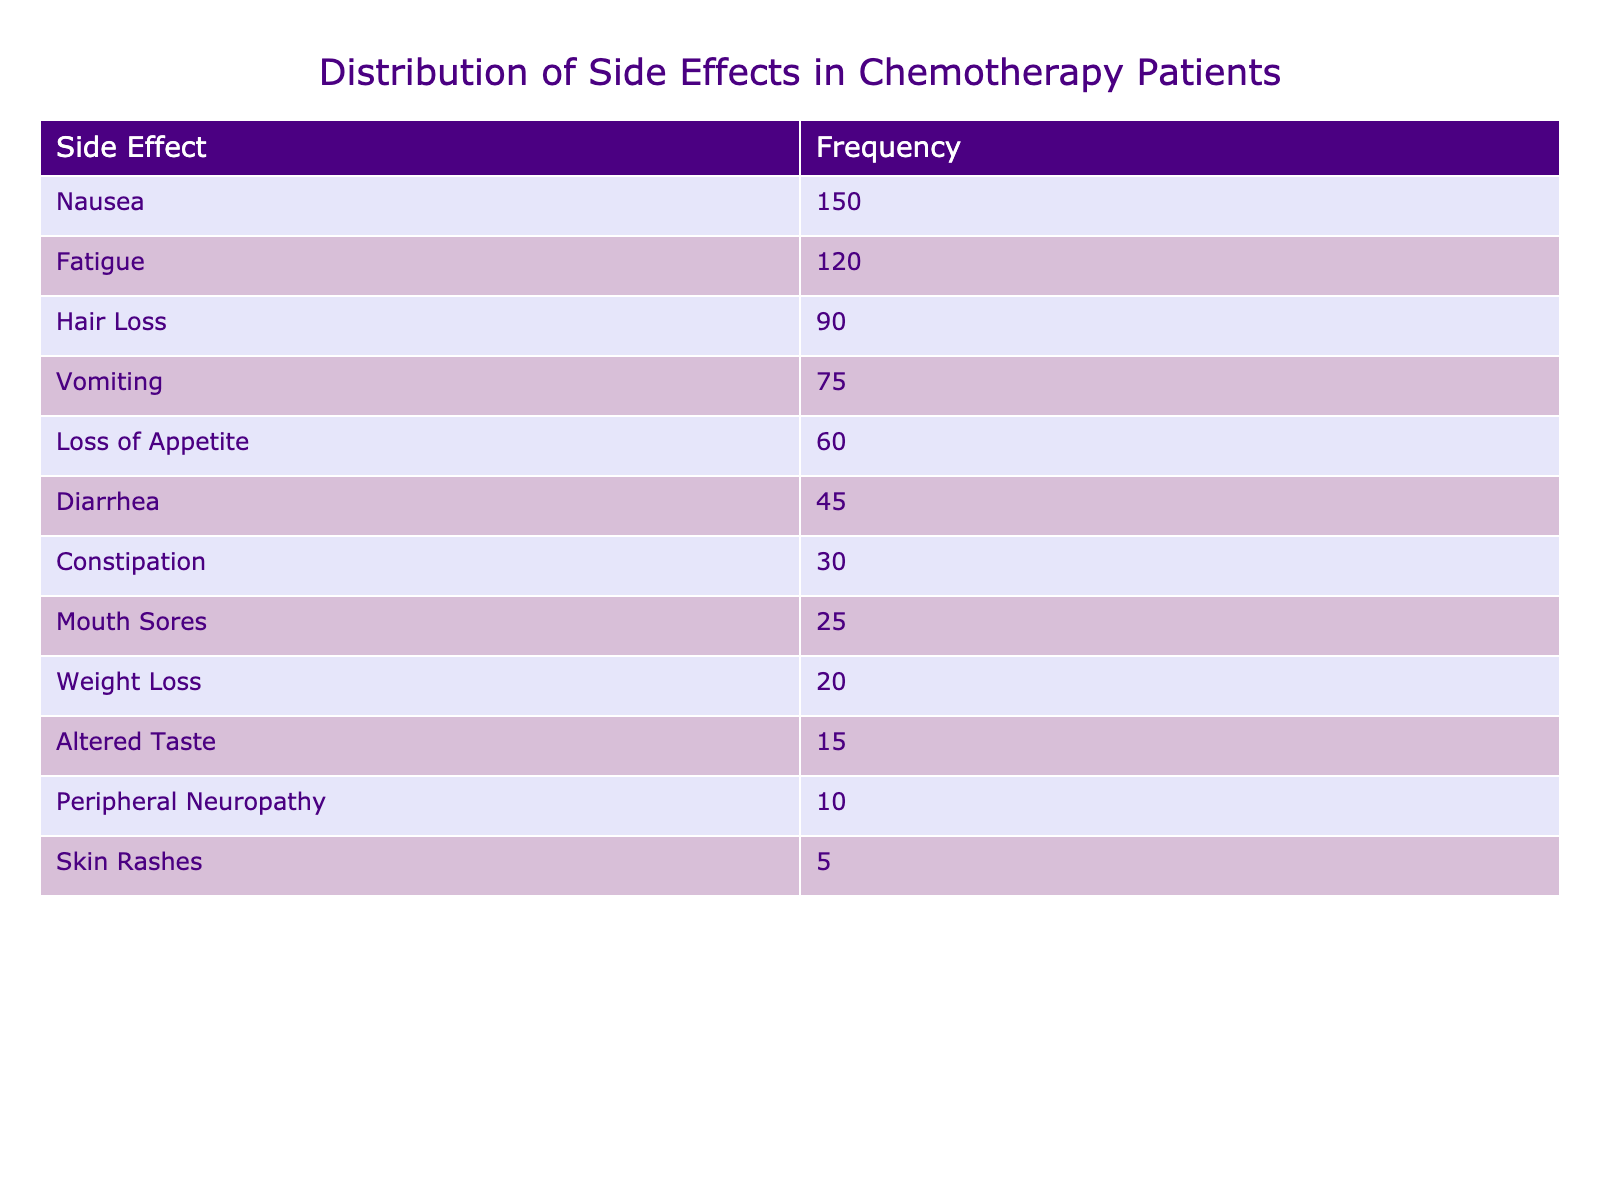What is the most reported side effect among chemotherapy patients? The table lists various side effects along with their reported frequencies. The side effect with the highest frequency is "Nausea" with a frequency of 150.
Answer: Nausea How many patients reported "Fatigue" as a side effect? The frequency table indicates that 120 patients reported experiencing "Fatigue" as a side effect of chemotherapy.
Answer: 120 What is the total frequency of all side effects reported? To find the total frequency, sum all the frequencies from the table: 150 + 120 + 90 + 75 + 60 + 45 + 30 + 25 + 20 + 15 + 10 + 5 =  630.
Answer: 630 Is "Hair Loss" reported more frequently than "Diarrhea"? "Hair Loss" has a frequency of 90 while "Diarrhea" has a frequency of 45. Since 90 is greater than 45, it is true that "Hair Loss" is reported more frequently than "Diarrhea".
Answer: Yes What are the two side effects with the lowest reported frequencies? The two side effects with the lowest frequencies from the table are "Skin Rashes" with 5 and "Peripheral Neuropathy" with 10.
Answer: Skin Rashes, Peripheral Neuropathy What is the difference in frequency between "Vomiting" and "Loss of Appetite"? The frequency for "Vomiting" is 75 and for "Loss of Appetite" is 60. The difference is calculated as 75 - 60 = 15.
Answer: 15 Which side effect was reported by fewer than 30 patients? From the table, only "Skin Rashes" (5) and "Peripheral Neuropathy" (10) were reported by fewer than 30 patients.
Answer: Skin Rashes, Peripheral Neuropathy What percentage of patients reported experiencing nausea? The frequency of nausea is 150, and the total frequency is 630. To find the percentage: (150 / 630) * 100 = 23.81%.
Answer: 23.81% How many side effects were reported by 60 or fewer patients? The side effects with frequencies of 60 or fewer are "Loss of Appetite" (60), "Diarrhea" (45), "Constipation" (30), "Mouth Sores" (25), "Weight Loss" (20), "Altered Taste" (15), "Peripheral Neuropathy" (10), and "Skin Rashes" (5). This totals to 8 side effects.
Answer: 8 